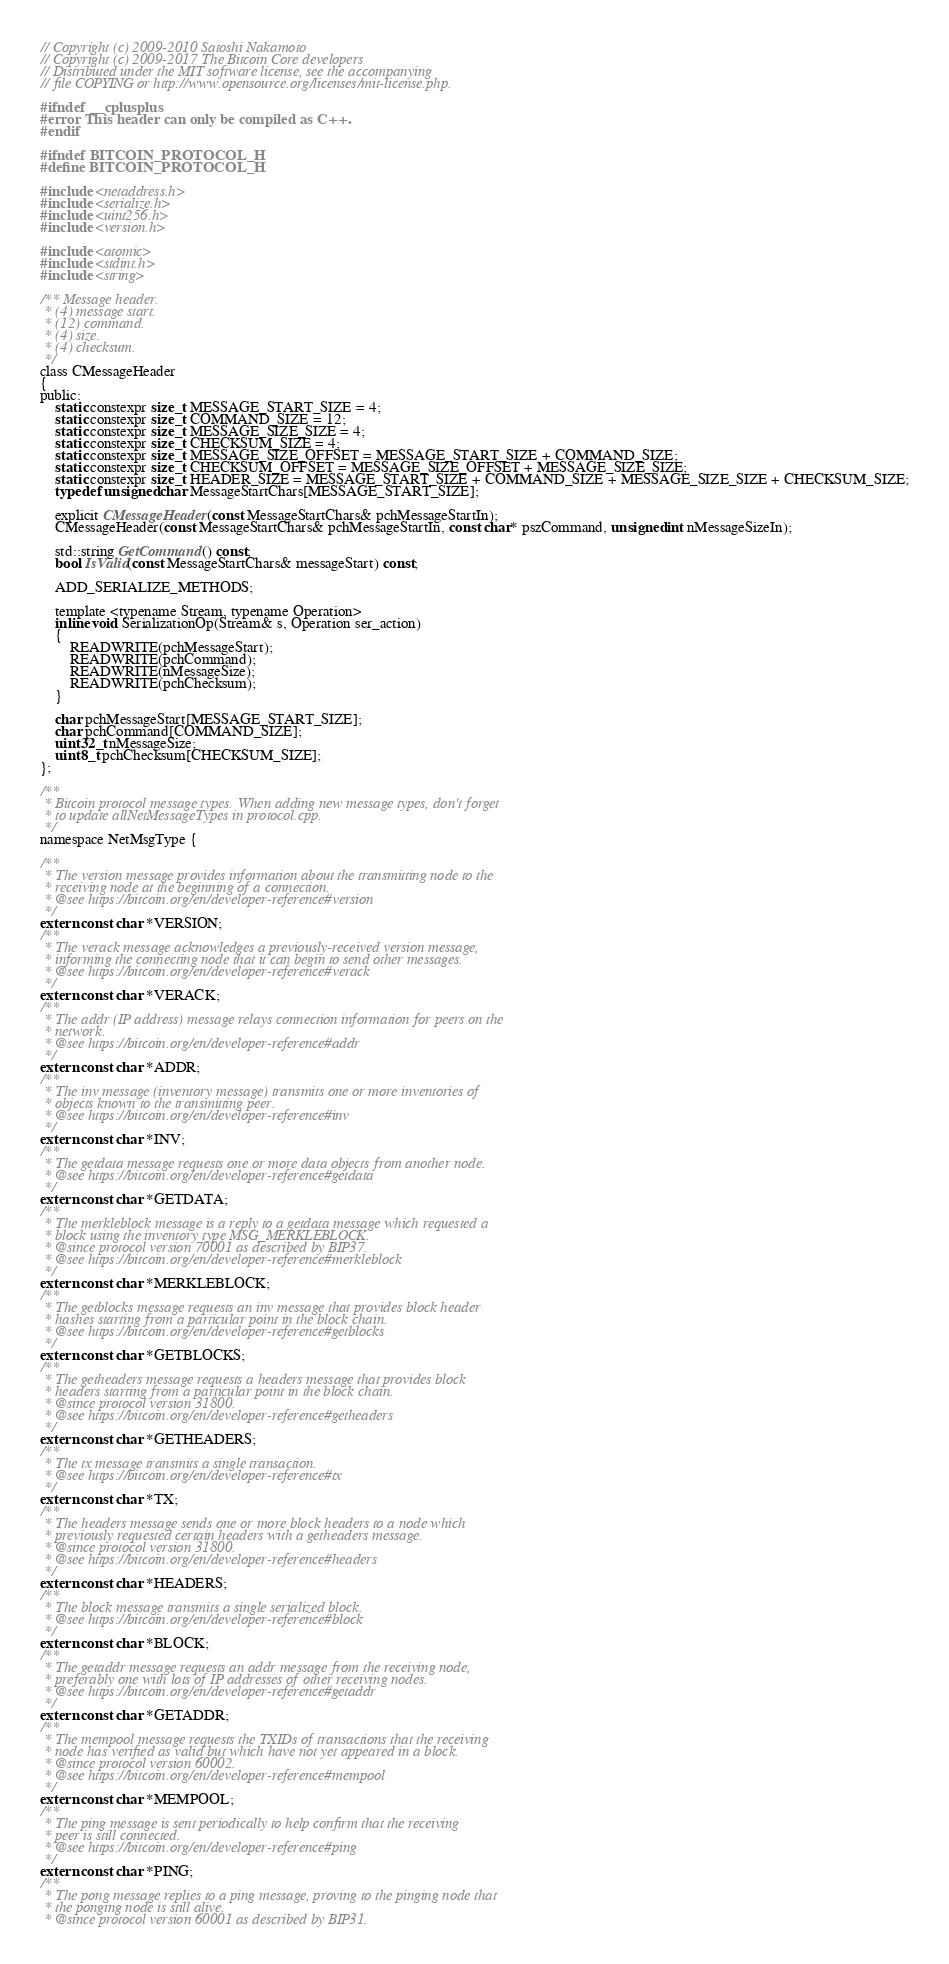Convert code to text. <code><loc_0><loc_0><loc_500><loc_500><_C_>// Copyright (c) 2009-2010 Satoshi Nakamoto
// Copyright (c) 2009-2017 The Bitcoin Core developers
// Distributed under the MIT software license, see the accompanying
// file COPYING or http://www.opensource.org/licenses/mit-license.php.

#ifndef __cplusplus
#error This header can only be compiled as C++.
#endif

#ifndef BITCOIN_PROTOCOL_H
#define BITCOIN_PROTOCOL_H

#include <netaddress.h>
#include <serialize.h>
#include <uint256.h>
#include <version.h>

#include <atomic>
#include <stdint.h>
#include <string>

/** Message header.
 * (4) message start.
 * (12) command.
 * (4) size.
 * (4) checksum.
 */
class CMessageHeader
{
public:
    static constexpr size_t MESSAGE_START_SIZE = 4;
    static constexpr size_t COMMAND_SIZE = 12;
    static constexpr size_t MESSAGE_SIZE_SIZE = 4;
    static constexpr size_t CHECKSUM_SIZE = 4;
    static constexpr size_t MESSAGE_SIZE_OFFSET = MESSAGE_START_SIZE + COMMAND_SIZE;
    static constexpr size_t CHECKSUM_OFFSET = MESSAGE_SIZE_OFFSET + MESSAGE_SIZE_SIZE;
    static constexpr size_t HEADER_SIZE = MESSAGE_START_SIZE + COMMAND_SIZE + MESSAGE_SIZE_SIZE + CHECKSUM_SIZE;
    typedef unsigned char MessageStartChars[MESSAGE_START_SIZE];

    explicit CMessageHeader(const MessageStartChars& pchMessageStartIn);
    CMessageHeader(const MessageStartChars& pchMessageStartIn, const char* pszCommand, unsigned int nMessageSizeIn);

    std::string GetCommand() const;
    bool IsValid(const MessageStartChars& messageStart) const;

    ADD_SERIALIZE_METHODS;

    template <typename Stream, typename Operation>
    inline void SerializationOp(Stream& s, Operation ser_action)
    {
        READWRITE(pchMessageStart);
        READWRITE(pchCommand);
        READWRITE(nMessageSize);
        READWRITE(pchChecksum);
    }

    char pchMessageStart[MESSAGE_START_SIZE];
    char pchCommand[COMMAND_SIZE];
    uint32_t nMessageSize;
    uint8_t pchChecksum[CHECKSUM_SIZE];
};

/**
 * Bitcoin protocol message types. When adding new message types, don't forget
 * to update allNetMessageTypes in protocol.cpp.
 */
namespace NetMsgType {

/**
 * The version message provides information about the transmitting node to the
 * receiving node at the beginning of a connection.
 * @see https://bitcoin.org/en/developer-reference#version
 */
extern const char *VERSION;
/**
 * The verack message acknowledges a previously-received version message,
 * informing the connecting node that it can begin to send other messages.
 * @see https://bitcoin.org/en/developer-reference#verack
 */
extern const char *VERACK;
/**
 * The addr (IP address) message relays connection information for peers on the
 * network.
 * @see https://bitcoin.org/en/developer-reference#addr
 */
extern const char *ADDR;
/**
 * The inv message (inventory message) transmits one or more inventories of
 * objects known to the transmitting peer.
 * @see https://bitcoin.org/en/developer-reference#inv
 */
extern const char *INV;
/**
 * The getdata message requests one or more data objects from another node.
 * @see https://bitcoin.org/en/developer-reference#getdata
 */
extern const char *GETDATA;
/**
 * The merkleblock message is a reply to a getdata message which requested a
 * block using the inventory type MSG_MERKLEBLOCK.
 * @since protocol version 70001 as described by BIP37.
 * @see https://bitcoin.org/en/developer-reference#merkleblock
 */
extern const char *MERKLEBLOCK;
/**
 * The getblocks message requests an inv message that provides block header
 * hashes starting from a particular point in the block chain.
 * @see https://bitcoin.org/en/developer-reference#getblocks
 */
extern const char *GETBLOCKS;
/**
 * The getheaders message requests a headers message that provides block
 * headers starting from a particular point in the block chain.
 * @since protocol version 31800.
 * @see https://bitcoin.org/en/developer-reference#getheaders
 */
extern const char *GETHEADERS;
/**
 * The tx message transmits a single transaction.
 * @see https://bitcoin.org/en/developer-reference#tx
 */
extern const char *TX;
/**
 * The headers message sends one or more block headers to a node which
 * previously requested certain headers with a getheaders message.
 * @since protocol version 31800.
 * @see https://bitcoin.org/en/developer-reference#headers
 */
extern const char *HEADERS;
/**
 * The block message transmits a single serialized block.
 * @see https://bitcoin.org/en/developer-reference#block
 */
extern const char *BLOCK;
/**
 * The getaddr message requests an addr message from the receiving node,
 * preferably one with lots of IP addresses of other receiving nodes.
 * @see https://bitcoin.org/en/developer-reference#getaddr
 */
extern const char *GETADDR;
/**
 * The mempool message requests the TXIDs of transactions that the receiving
 * node has verified as valid but which have not yet appeared in a block.
 * @since protocol version 60002.
 * @see https://bitcoin.org/en/developer-reference#mempool
 */
extern const char *MEMPOOL;
/**
 * The ping message is sent periodically to help confirm that the receiving
 * peer is still connected.
 * @see https://bitcoin.org/en/developer-reference#ping
 */
extern const char *PING;
/**
 * The pong message replies to a ping message, proving to the pinging node that
 * the ponging node is still alive.
 * @since protocol version 60001 as described by BIP31.</code> 